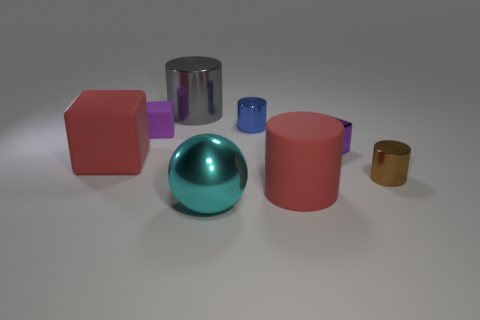How many objects are either big matte things to the right of the gray object or cylinders that are left of the small blue cylinder?
Your answer should be compact. 2. What is the shape of the blue thing?
Offer a very short reply. Cylinder. What shape is the tiny object that is the same color as the small matte cube?
Ensure brevity in your answer.  Cube. What number of big gray cylinders have the same material as the small brown thing?
Your answer should be very brief. 1. What color is the big sphere?
Keep it short and to the point. Cyan. What is the color of the shiny cube that is the same size as the purple rubber thing?
Ensure brevity in your answer.  Purple. Is there another sphere of the same color as the large sphere?
Your answer should be compact. No. Do the large red thing that is in front of the red cube and the large metallic object behind the tiny brown metal cylinder have the same shape?
Your response must be concise. Yes. There is a object that is the same color as the large cube; what is its size?
Provide a succinct answer. Large. What number of other things are the same size as the blue cylinder?
Keep it short and to the point. 3. 